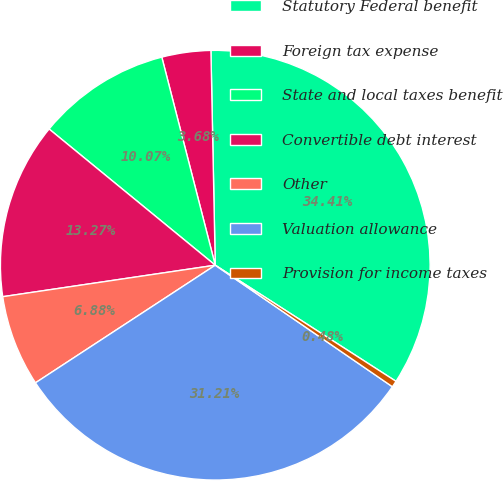Convert chart to OTSL. <chart><loc_0><loc_0><loc_500><loc_500><pie_chart><fcel>Statutory Federal benefit<fcel>Foreign tax expense<fcel>State and local taxes benefit<fcel>Convertible debt interest<fcel>Other<fcel>Valuation allowance<fcel>Provision for income taxes<nl><fcel>34.41%<fcel>3.68%<fcel>10.07%<fcel>13.27%<fcel>6.88%<fcel>31.21%<fcel>0.48%<nl></chart> 